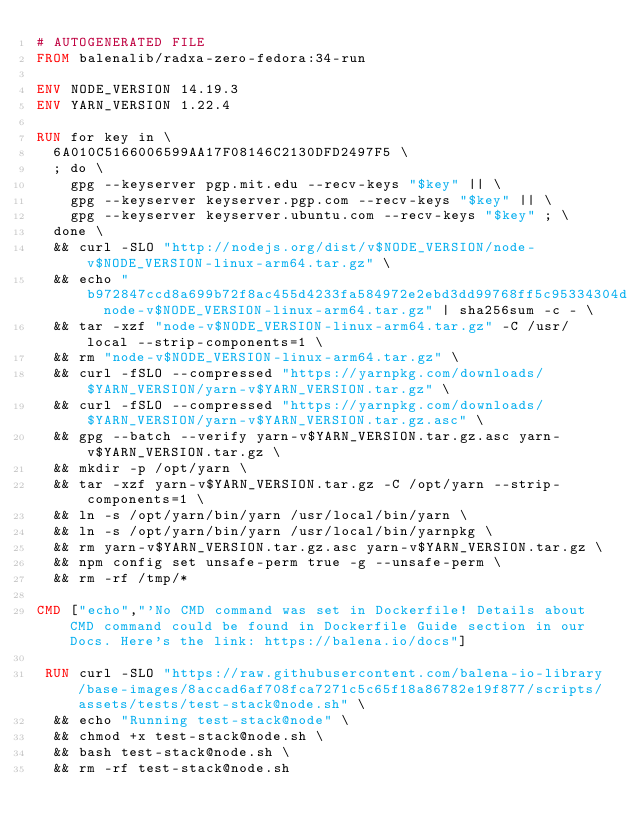<code> <loc_0><loc_0><loc_500><loc_500><_Dockerfile_># AUTOGENERATED FILE
FROM balenalib/radxa-zero-fedora:34-run

ENV NODE_VERSION 14.19.3
ENV YARN_VERSION 1.22.4

RUN for key in \
	6A010C5166006599AA17F08146C2130DFD2497F5 \
	; do \
		gpg --keyserver pgp.mit.edu --recv-keys "$key" || \
		gpg --keyserver keyserver.pgp.com --recv-keys "$key" || \
		gpg --keyserver keyserver.ubuntu.com --recv-keys "$key" ; \
	done \
	&& curl -SLO "http://nodejs.org/dist/v$NODE_VERSION/node-v$NODE_VERSION-linux-arm64.tar.gz" \
	&& echo "b972847ccd8a699b72f8ac455d4233fa584972e2ebd3dd99768ff5c95334304d  node-v$NODE_VERSION-linux-arm64.tar.gz" | sha256sum -c - \
	&& tar -xzf "node-v$NODE_VERSION-linux-arm64.tar.gz" -C /usr/local --strip-components=1 \
	&& rm "node-v$NODE_VERSION-linux-arm64.tar.gz" \
	&& curl -fSLO --compressed "https://yarnpkg.com/downloads/$YARN_VERSION/yarn-v$YARN_VERSION.tar.gz" \
	&& curl -fSLO --compressed "https://yarnpkg.com/downloads/$YARN_VERSION/yarn-v$YARN_VERSION.tar.gz.asc" \
	&& gpg --batch --verify yarn-v$YARN_VERSION.tar.gz.asc yarn-v$YARN_VERSION.tar.gz \
	&& mkdir -p /opt/yarn \
	&& tar -xzf yarn-v$YARN_VERSION.tar.gz -C /opt/yarn --strip-components=1 \
	&& ln -s /opt/yarn/bin/yarn /usr/local/bin/yarn \
	&& ln -s /opt/yarn/bin/yarn /usr/local/bin/yarnpkg \
	&& rm yarn-v$YARN_VERSION.tar.gz.asc yarn-v$YARN_VERSION.tar.gz \
	&& npm config set unsafe-perm true -g --unsafe-perm \
	&& rm -rf /tmp/*

CMD ["echo","'No CMD command was set in Dockerfile! Details about CMD command could be found in Dockerfile Guide section in our Docs. Here's the link: https://balena.io/docs"]

 RUN curl -SLO "https://raw.githubusercontent.com/balena-io-library/base-images/8accad6af708fca7271c5c65f18a86782e19f877/scripts/assets/tests/test-stack@node.sh" \
  && echo "Running test-stack@node" \
  && chmod +x test-stack@node.sh \
  && bash test-stack@node.sh \
  && rm -rf test-stack@node.sh 
</code> 